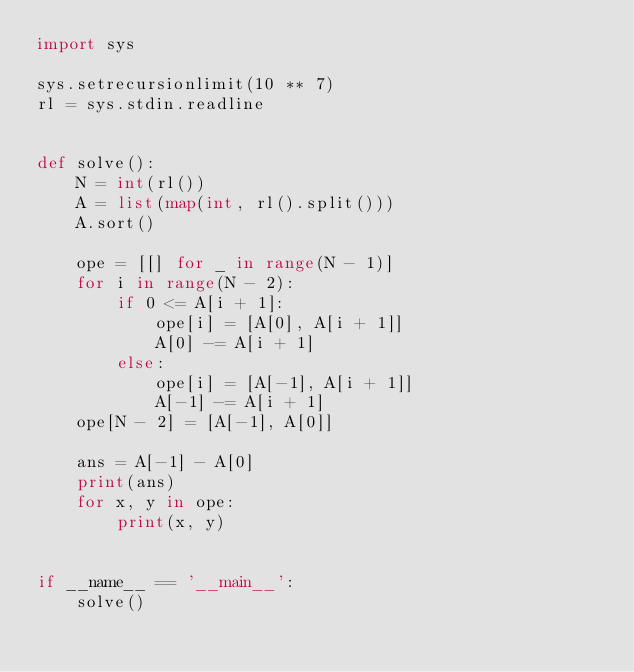Convert code to text. <code><loc_0><loc_0><loc_500><loc_500><_Python_>import sys

sys.setrecursionlimit(10 ** 7)
rl = sys.stdin.readline


def solve():
    N = int(rl())
    A = list(map(int, rl().split()))
    A.sort()
    
    ope = [[] for _ in range(N - 1)]
    for i in range(N - 2):
        if 0 <= A[i + 1]:
            ope[i] = [A[0], A[i + 1]]
            A[0] -= A[i + 1]
        else:
            ope[i] = [A[-1], A[i + 1]]
            A[-1] -= A[i + 1]
    ope[N - 2] = [A[-1], A[0]]
    
    ans = A[-1] - A[0]
    print(ans)
    for x, y in ope:
        print(x, y)


if __name__ == '__main__':
    solve()
</code> 